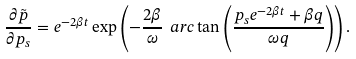<formula> <loc_0><loc_0><loc_500><loc_500>\frac { \partial \tilde { p } } { \partial p _ { s } } = e ^ { - 2 \beta t } \exp \left ( - \frac { 2 \beta } { \omega } \ a r c \tan \left ( \frac { p _ { s } e ^ { - 2 \beta t } + \beta q } { \omega q } \right ) \right ) .</formula> 